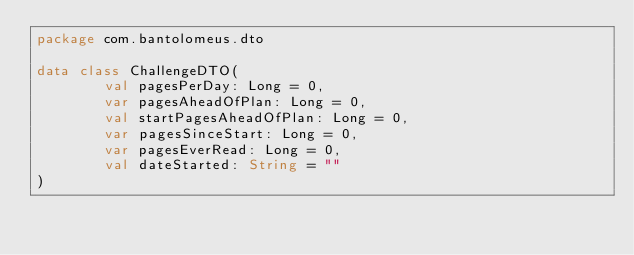<code> <loc_0><loc_0><loc_500><loc_500><_Kotlin_>package com.bantolomeus.dto

data class ChallengeDTO(
        val pagesPerDay: Long = 0,
        var pagesAheadOfPlan: Long = 0,
        val startPagesAheadOfPlan: Long = 0,
        var pagesSinceStart: Long = 0,
        var pagesEverRead: Long = 0,
        val dateStarted: String = ""
)
</code> 